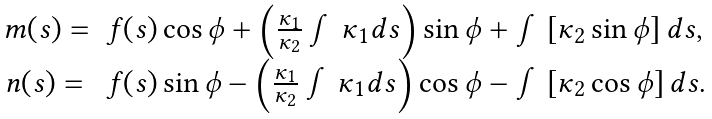Convert formula to latex. <formula><loc_0><loc_0><loc_500><loc_500>\begin{array} { l l } m ( s ) = & f ( s ) \cos \phi + \left ( \frac { \kappa _ { 1 } } { \kappa _ { 2 } } \int \kappa _ { 1 } d s \right ) \sin \phi + \int \left [ \kappa _ { 2 } \sin \phi \right ] d s , \\ n ( s ) = & f ( s ) \sin \phi - \left ( \frac { \kappa _ { 1 } } { \kappa _ { 2 } } \int \kappa _ { 1 } d s \right ) \cos \phi - \int \left [ \kappa _ { 2 } \cos \phi \right ] d s . \end{array}</formula> 